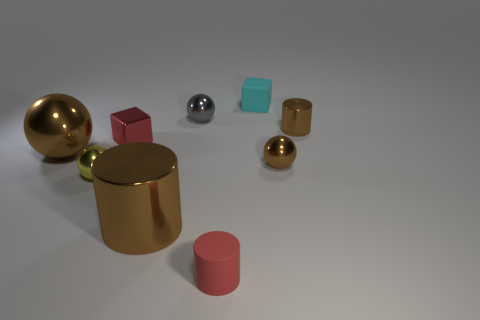Are there any cyan objects made of the same material as the large brown cylinder?
Your answer should be very brief. No. What material is the brown cylinder that is the same size as the cyan matte object?
Your answer should be compact. Metal. What size is the brown ball to the left of the small brown metal object in front of the cylinder to the right of the tiny cyan thing?
Make the answer very short. Large. There is a small ball to the right of the small matte block; is there a block that is to the right of it?
Ensure brevity in your answer.  No. Does the small yellow object have the same shape as the big object that is on the left side of the small yellow metallic sphere?
Provide a short and direct response. Yes. What color is the matte thing behind the tiny red matte object?
Provide a short and direct response. Cyan. There is a metallic ball that is behind the red object behind the small yellow shiny object; what is its size?
Provide a succinct answer. Small. There is a tiny red object in front of the yellow thing; is its shape the same as the small cyan matte object?
Provide a short and direct response. No. There is another small thing that is the same shape as the small red shiny thing; what material is it?
Your response must be concise. Rubber. How many objects are either matte things in front of the cyan rubber block or small metallic objects that are behind the small red metal object?
Offer a very short reply. 3. 